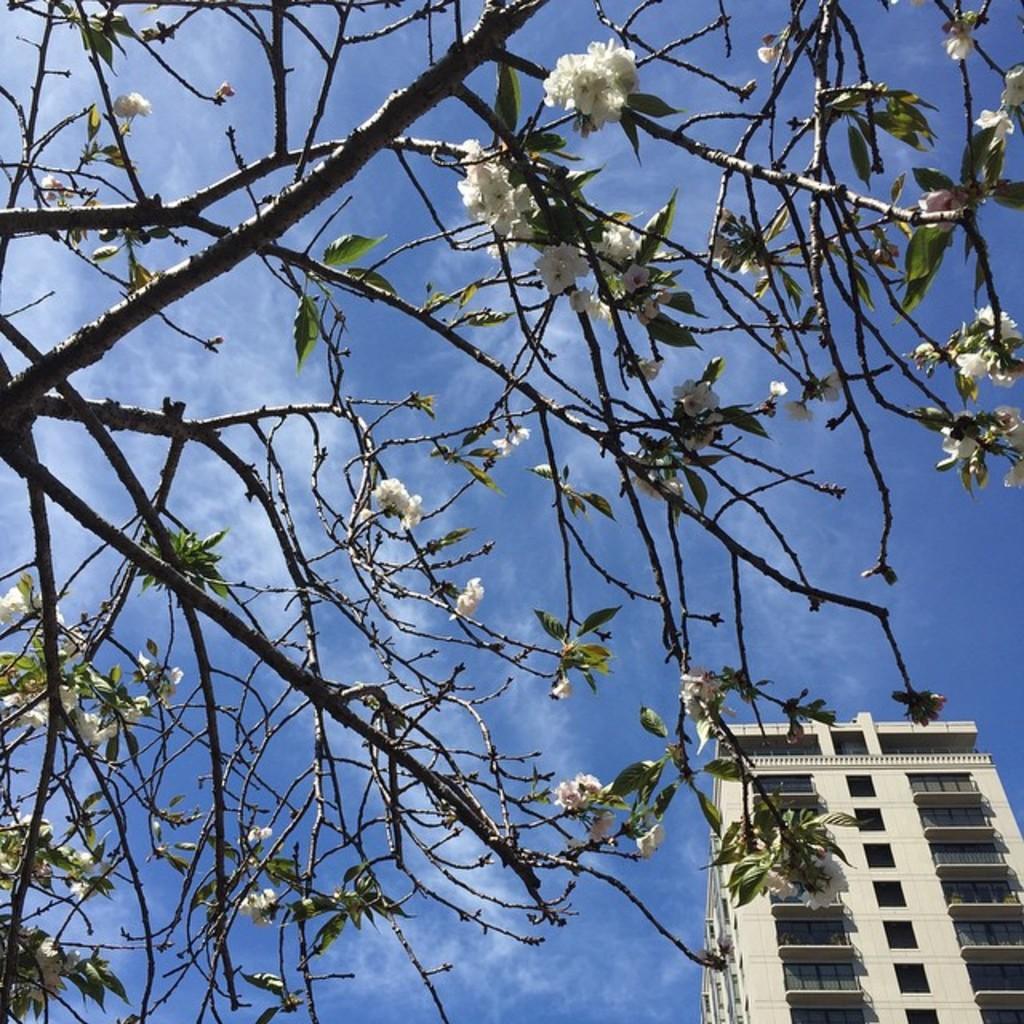Describe this image in one or two sentences. There is white flowers tree and a building at the back. 